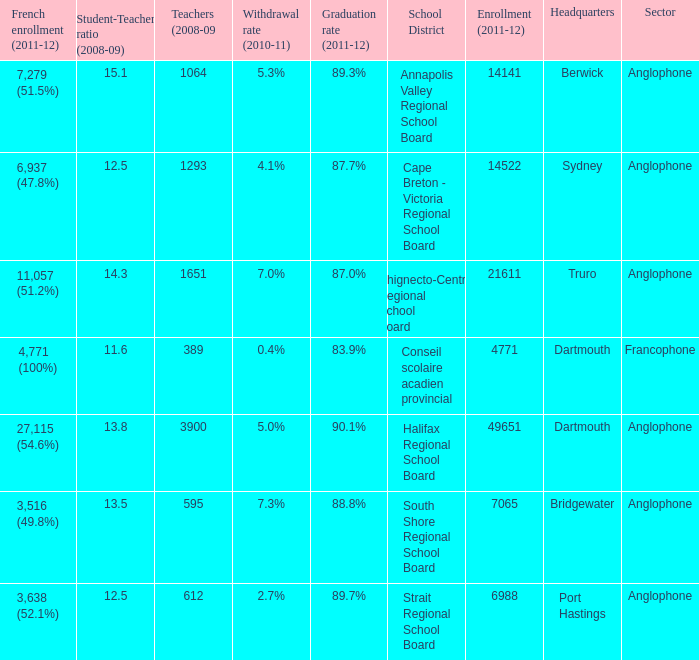What is their withdrawal rate for the school district with headquarters located in Truro? 7.0%. 